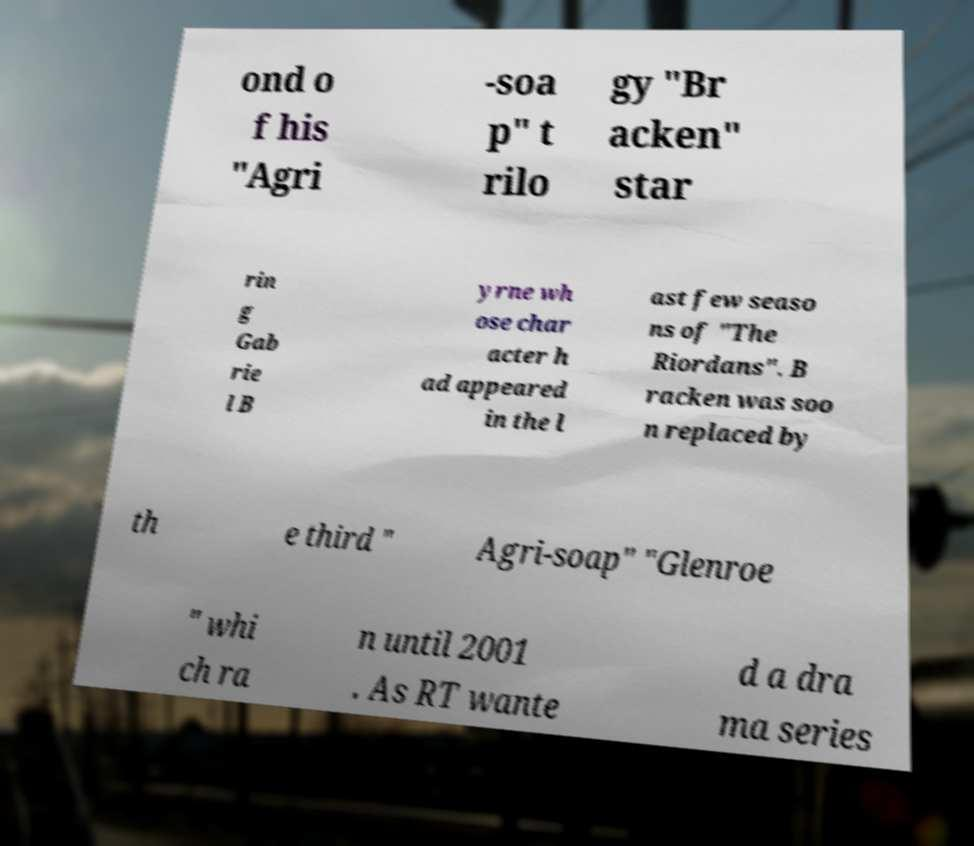What messages or text are displayed in this image? I need them in a readable, typed format. ond o f his "Agri -soa p" t rilo gy "Br acken" star rin g Gab rie l B yrne wh ose char acter h ad appeared in the l ast few seaso ns of "The Riordans". B racken was soo n replaced by th e third " Agri-soap" "Glenroe " whi ch ra n until 2001 . As RT wante d a dra ma series 